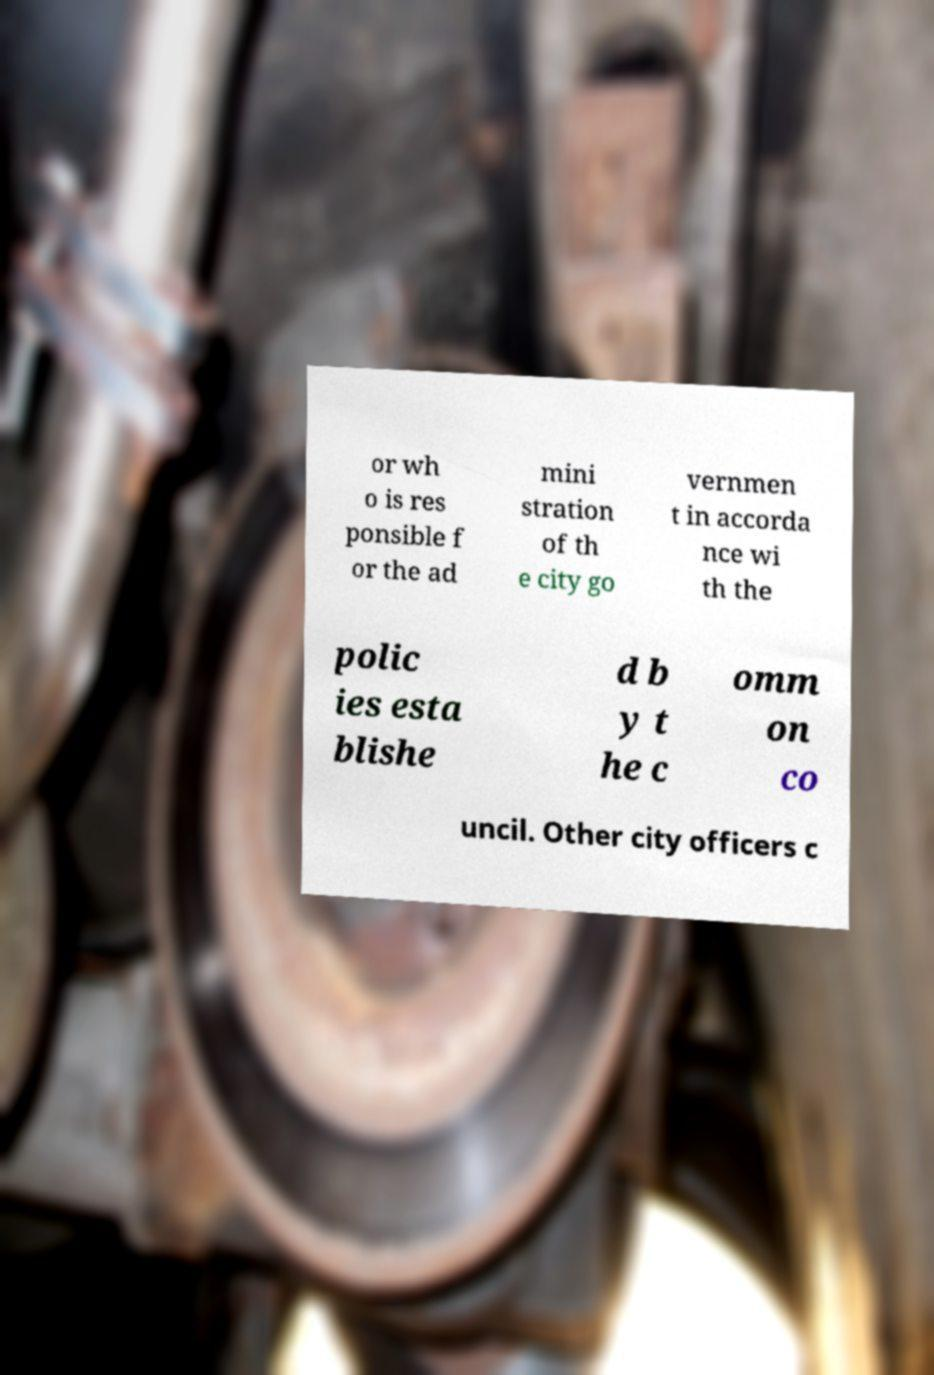There's text embedded in this image that I need extracted. Can you transcribe it verbatim? or wh o is res ponsible f or the ad mini stration of th e city go vernmen t in accorda nce wi th the polic ies esta blishe d b y t he c omm on co uncil. Other city officers c 